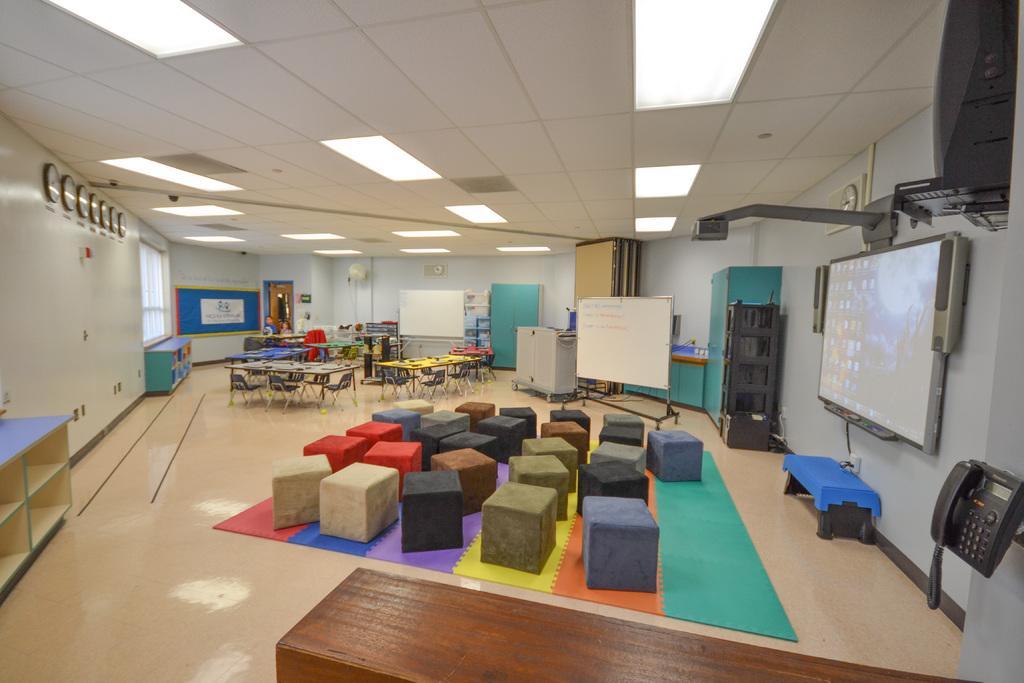In one or two sentences, can you explain what this image depicts? In the picture I can see the screen on the wall on the right side and there is a projector arrangement as well. There is a telephone on the bottom right side of the picture. I can see the carpet on the floor, on the carpet I can see the square structure sofas. I can see the tables and chairs on the floor. I can see a white board stand on the floor. I can see the clocks on the wall on the top left side. There are wooden drawers on the floor. There is a lighting arrangement on the roof. 